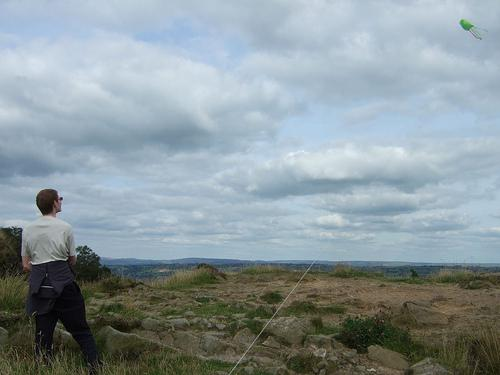Question: how does the sky look?
Choices:
A. Cloudy.
B. Very clear.
C. Blue.
D. Stormy.
Answer with the letter. Answer: B Question: what color are the rocks?
Choices:
A. Grey.
B. Brown.
C. Charcoal.
D. Red.
Answer with the letter. Answer: A Question: what is the man doing?
Choices:
A. Running.
B. Jogging.
C. Flying a kite.
D. Walking a trail.
Answer with the letter. Answer: C Question: who took the photo?
Choices:
A. Me.
B. A man.
C. Max.
D. A little girl.
Answer with the letter. Answer: C Question: what are in the distance?
Choices:
A. Mountains.
B. Flowers.
C. Trees.
D. Grass.
Answer with the letter. Answer: C 